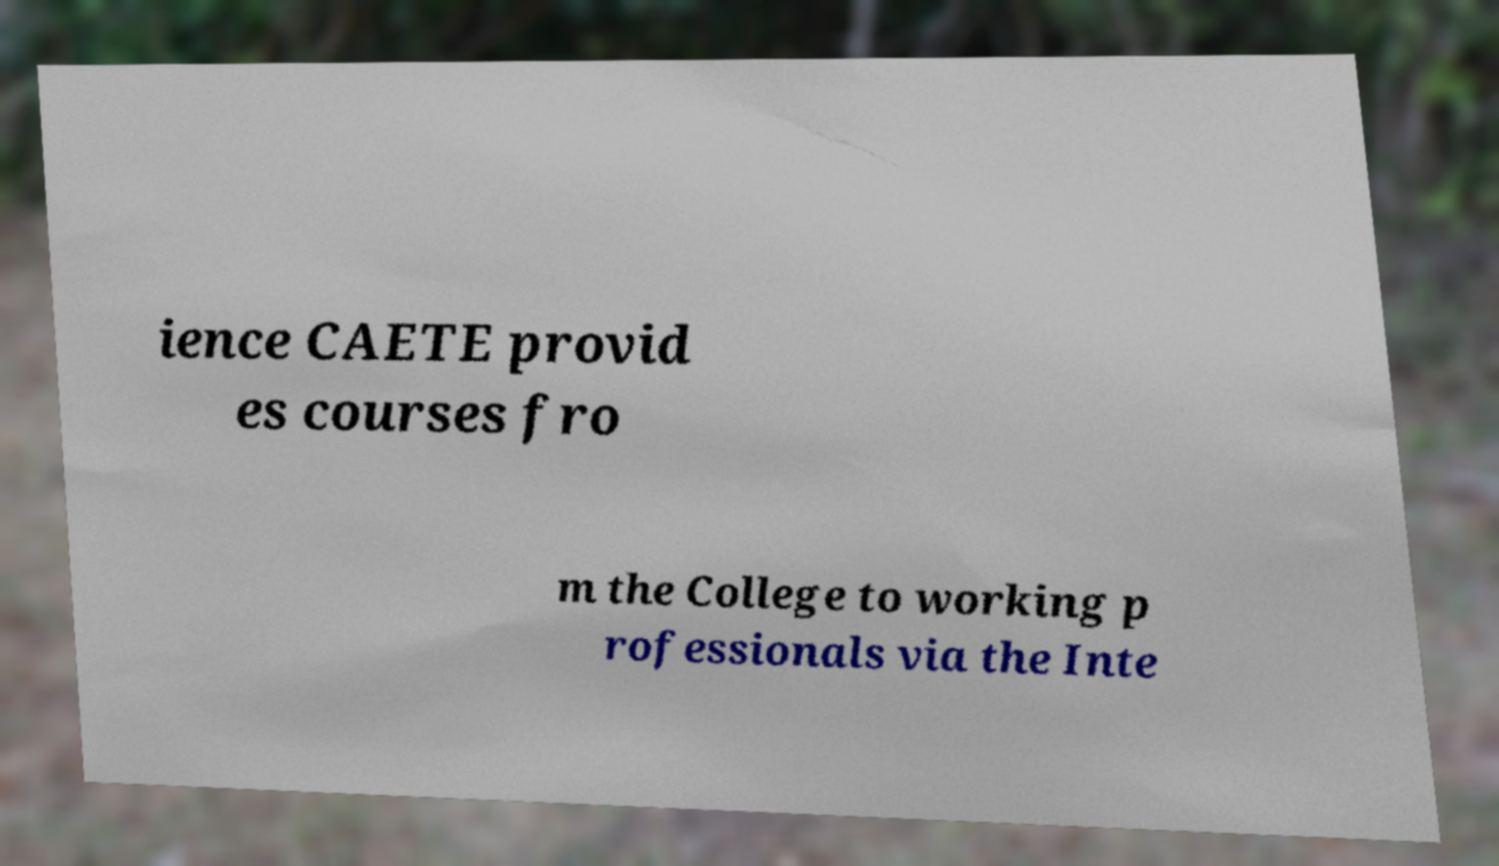What messages or text are displayed in this image? I need them in a readable, typed format. ience CAETE provid es courses fro m the College to working p rofessionals via the Inte 